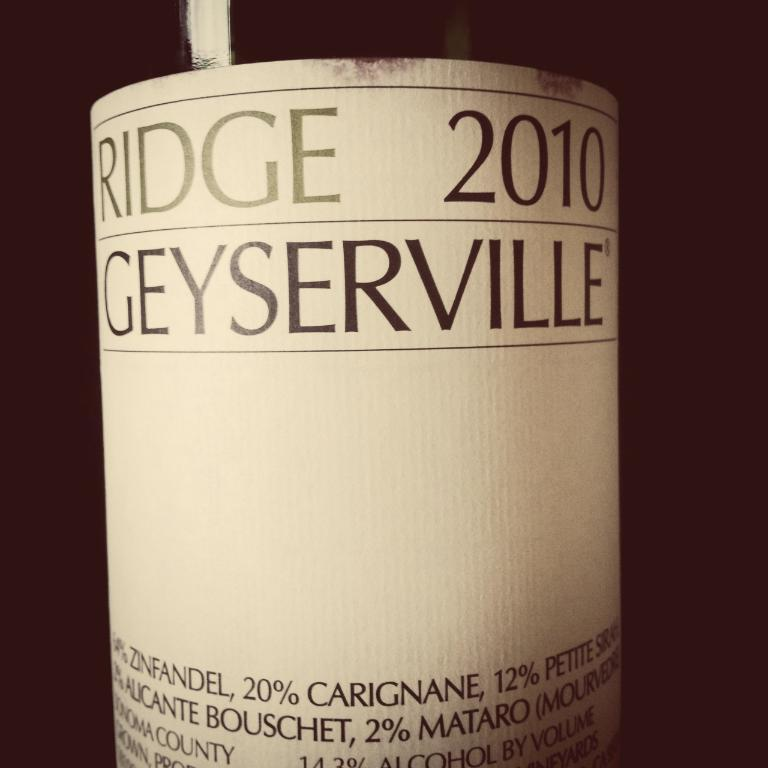<image>
Offer a succinct explanation of the picture presented. A bottle of Ridge 2010 Geyserville sits against a dark backdrop 